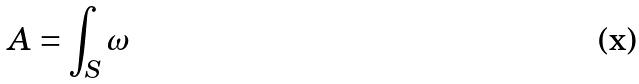<formula> <loc_0><loc_0><loc_500><loc_500>A = \int _ { S } \omega</formula> 